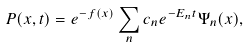Convert formula to latex. <formula><loc_0><loc_0><loc_500><loc_500>P ( x , t ) = e ^ { - f ( x ) } \sum _ { n } c _ { n } e ^ { - E _ { n } t } \Psi _ { n } ( x ) ,</formula> 